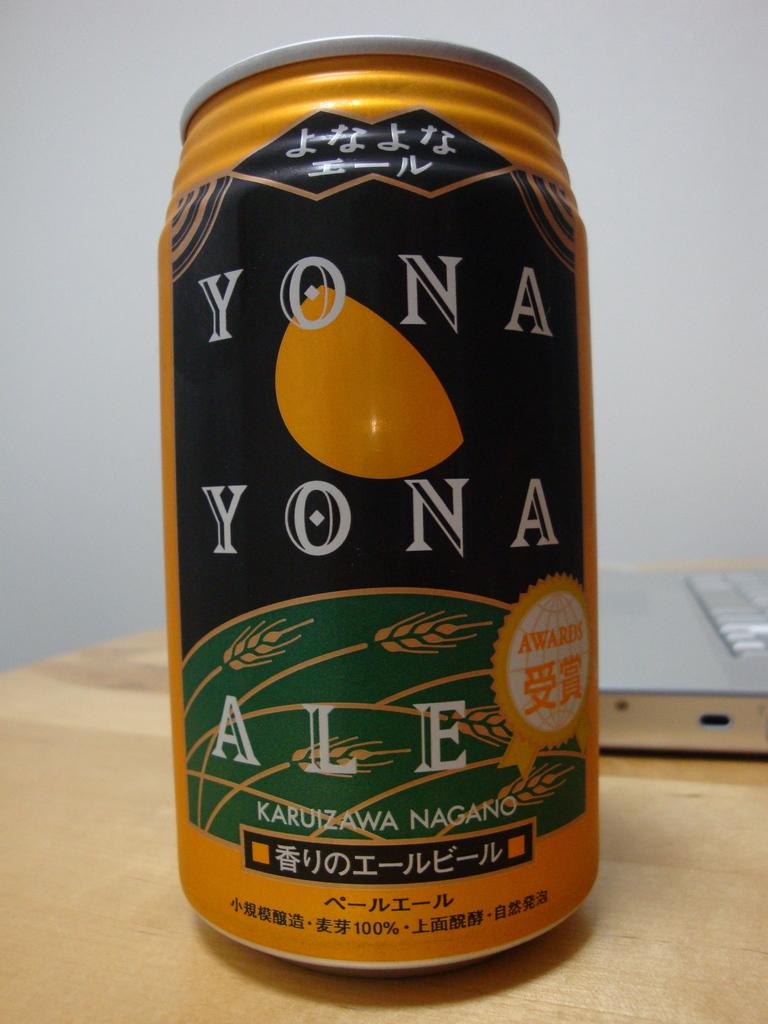<image>
Render a clear and concise summary of the photo. A can of Yona Yona ale sits on a wooden table. 